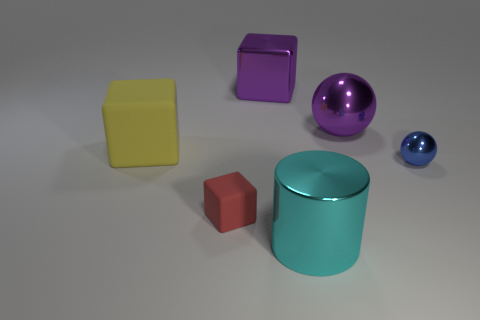What is the size of the other shiny thing that is the same shape as the small red object?
Your answer should be very brief. Large. What is the blue sphere made of?
Make the answer very short. Metal. What is the material of the cube in front of the rubber block that is on the left side of the small thing to the left of the cyan metallic object?
Your answer should be very brief. Rubber. Is there any other thing that is the same shape as the small blue shiny object?
Keep it short and to the point. Yes. The other big object that is the same shape as the large yellow thing is what color?
Your answer should be compact. Purple. There is a rubber cube that is behind the blue ball; does it have the same color as the sphere that is behind the big yellow matte object?
Offer a very short reply. No. Are there more large things that are behind the purple shiny cube than objects?
Offer a terse response. No. What number of other objects are the same size as the red rubber thing?
Provide a succinct answer. 1. What number of large objects are in front of the red cube and behind the blue shiny ball?
Your answer should be very brief. 0. Is the small thing to the left of the blue object made of the same material as the big purple ball?
Keep it short and to the point. No. 